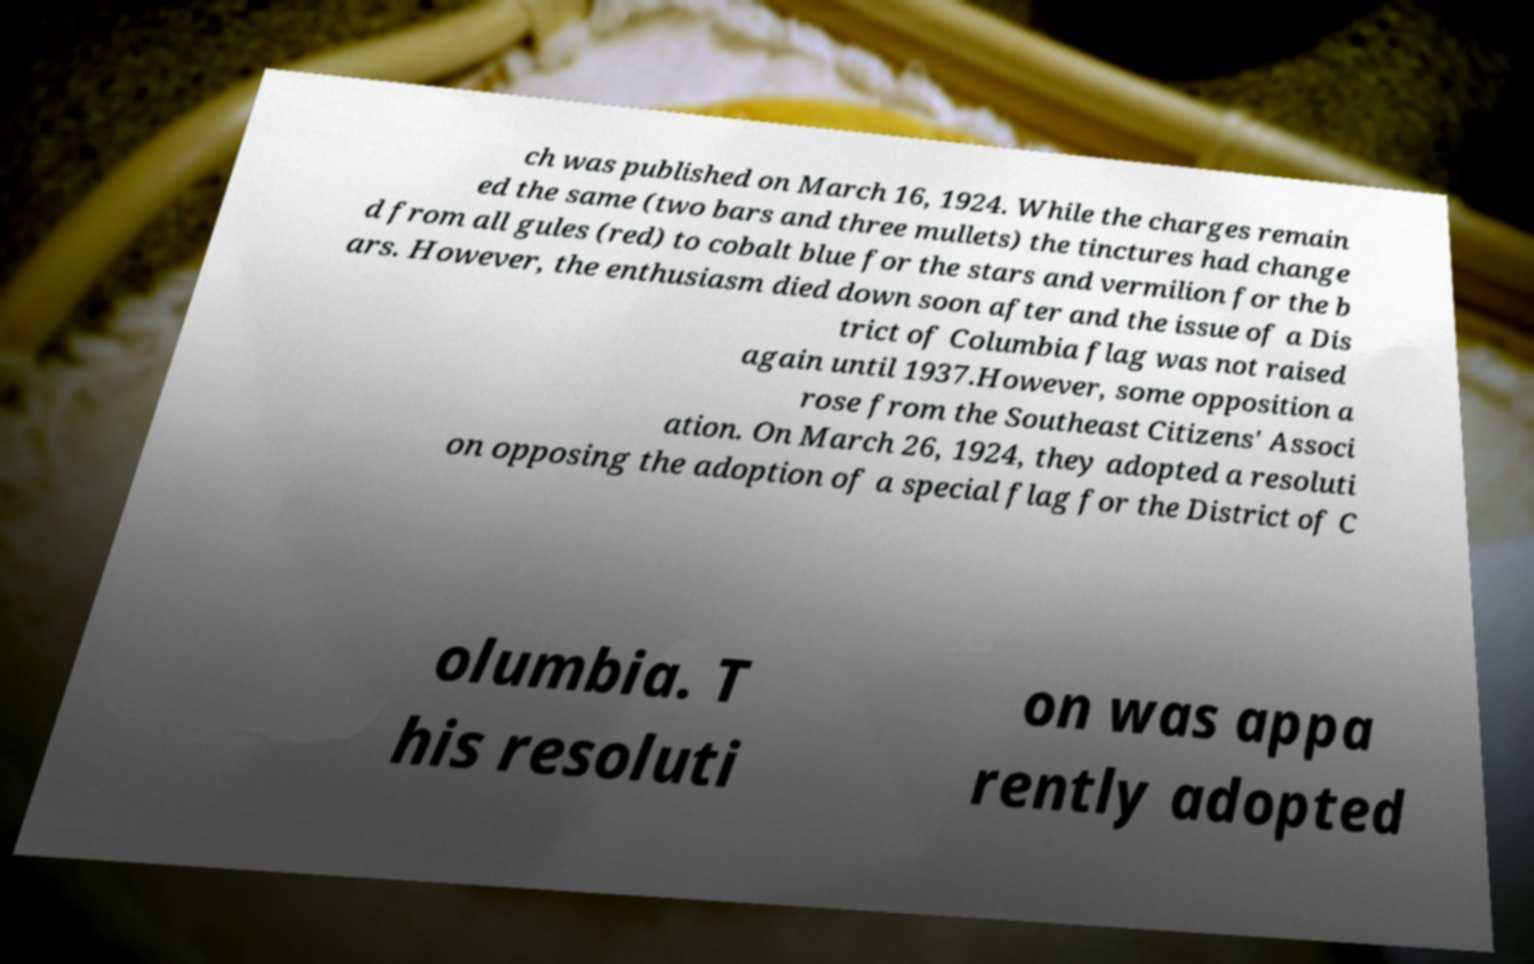Please identify and transcribe the text found in this image. ch was published on March 16, 1924. While the charges remain ed the same (two bars and three mullets) the tinctures had change d from all gules (red) to cobalt blue for the stars and vermilion for the b ars. However, the enthusiasm died down soon after and the issue of a Dis trict of Columbia flag was not raised again until 1937.However, some opposition a rose from the Southeast Citizens' Associ ation. On March 26, 1924, they adopted a resoluti on opposing the adoption of a special flag for the District of C olumbia. T his resoluti on was appa rently adopted 